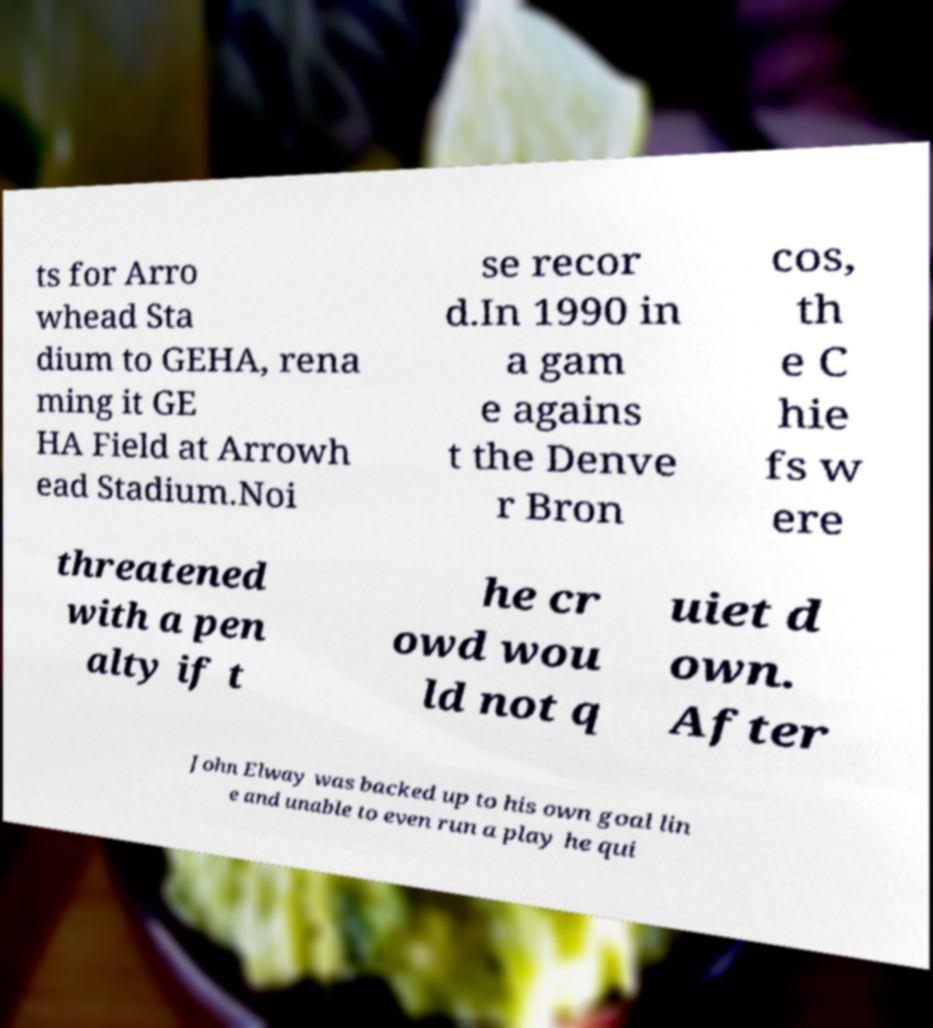What messages or text are displayed in this image? I need them in a readable, typed format. ts for Arro whead Sta dium to GEHA, rena ming it GE HA Field at Arrowh ead Stadium.Noi se recor d.In 1990 in a gam e agains t the Denve r Bron cos, th e C hie fs w ere threatened with a pen alty if t he cr owd wou ld not q uiet d own. After John Elway was backed up to his own goal lin e and unable to even run a play he qui 